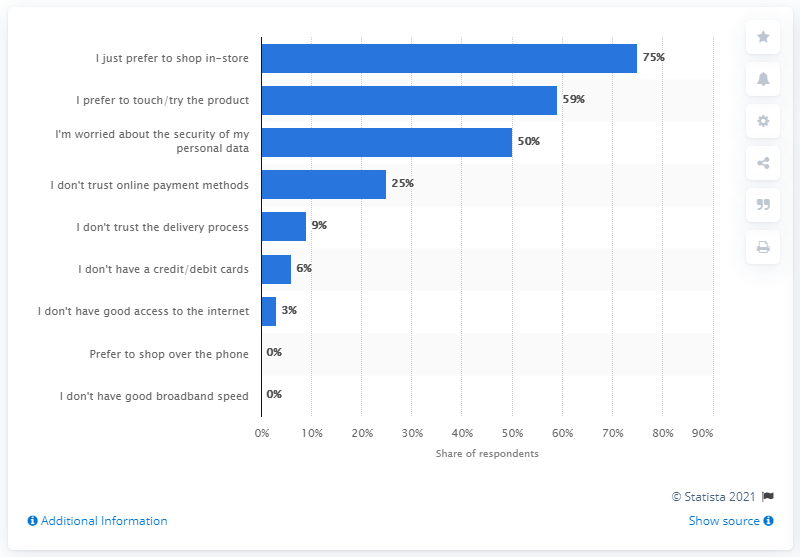Indicate a few pertinent items in this graphic. It is possible to have opinions with a 0% rating. The average of the highest three values is 61.3. 